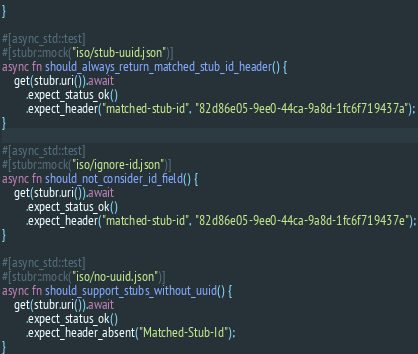Convert code to text. <code><loc_0><loc_0><loc_500><loc_500><_Rust_>}

#[async_std::test]
#[stubr::mock("iso/stub-uuid.json")]
async fn should_always_return_matched_stub_id_header() {
    get(stubr.uri()).await
        .expect_status_ok()
        .expect_header("matched-stub-id", "82d86e05-9ee0-44ca-9a8d-1fc6f719437a");
}

#[async_std::test]
#[stubr::mock("iso/ignore-id.json")]
async fn should_not_consider_id_field() {
    get(stubr.uri()).await
        .expect_status_ok()
        .expect_header("matched-stub-id", "82d86e05-9ee0-44ca-9a8d-1fc6f719437e");
}

#[async_std::test]
#[stubr::mock("iso/no-uuid.json")]
async fn should_support_stubs_without_uuid() {
    get(stubr.uri()).await
        .expect_status_ok()
        .expect_header_absent("Matched-Stub-Id");
}</code> 